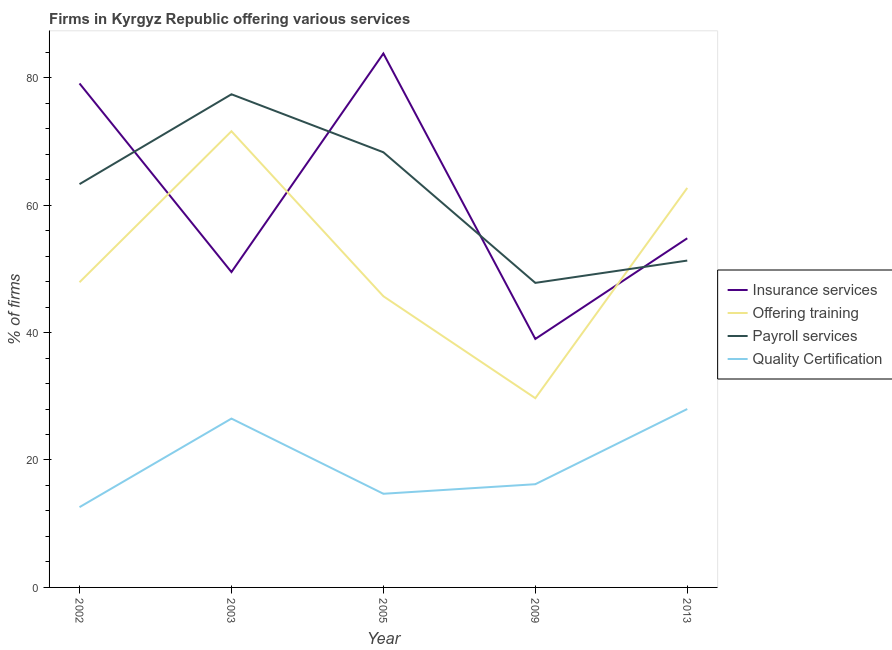Does the line corresponding to percentage of firms offering training intersect with the line corresponding to percentage of firms offering payroll services?
Keep it short and to the point. Yes. Is the number of lines equal to the number of legend labels?
Ensure brevity in your answer.  Yes. What is the percentage of firms offering insurance services in 2005?
Offer a terse response. 83.8. Across all years, what is the maximum percentage of firms offering insurance services?
Your answer should be compact. 83.8. Across all years, what is the minimum percentage of firms offering training?
Your answer should be very brief. 29.7. What is the total percentage of firms offering payroll services in the graph?
Give a very brief answer. 308.1. What is the difference between the percentage of firms offering payroll services in 2003 and that in 2013?
Provide a succinct answer. 26.1. What is the difference between the percentage of firms offering training in 2002 and the percentage of firms offering insurance services in 2003?
Your answer should be very brief. -1.6. What is the average percentage of firms offering payroll services per year?
Ensure brevity in your answer.  61.62. What is the ratio of the percentage of firms offering payroll services in 2005 to that in 2013?
Your response must be concise. 1.33. Is the difference between the percentage of firms offering quality certification in 2009 and 2013 greater than the difference between the percentage of firms offering training in 2009 and 2013?
Offer a terse response. Yes. What is the difference between the highest and the lowest percentage of firms offering payroll services?
Offer a very short reply. 29.6. In how many years, is the percentage of firms offering quality certification greater than the average percentage of firms offering quality certification taken over all years?
Provide a succinct answer. 2. Is the sum of the percentage of firms offering quality certification in 2002 and 2013 greater than the maximum percentage of firms offering training across all years?
Ensure brevity in your answer.  No. Is it the case that in every year, the sum of the percentage of firms offering quality certification and percentage of firms offering insurance services is greater than the sum of percentage of firms offering payroll services and percentage of firms offering training?
Your response must be concise. No. Does the percentage of firms offering insurance services monotonically increase over the years?
Keep it short and to the point. No. Is the percentage of firms offering payroll services strictly less than the percentage of firms offering training over the years?
Offer a very short reply. No. How many lines are there?
Offer a terse response. 4. How many years are there in the graph?
Provide a succinct answer. 5. Are the values on the major ticks of Y-axis written in scientific E-notation?
Ensure brevity in your answer.  No. Does the graph contain any zero values?
Give a very brief answer. No. Does the graph contain grids?
Keep it short and to the point. No. How are the legend labels stacked?
Make the answer very short. Vertical. What is the title of the graph?
Offer a terse response. Firms in Kyrgyz Republic offering various services . What is the label or title of the X-axis?
Your answer should be very brief. Year. What is the label or title of the Y-axis?
Your answer should be compact. % of firms. What is the % of firms in Insurance services in 2002?
Keep it short and to the point. 79.1. What is the % of firms in Offering training in 2002?
Make the answer very short. 47.9. What is the % of firms in Payroll services in 2002?
Ensure brevity in your answer.  63.3. What is the % of firms in Quality Certification in 2002?
Ensure brevity in your answer.  12.6. What is the % of firms of Insurance services in 2003?
Your response must be concise. 49.5. What is the % of firms of Offering training in 2003?
Your response must be concise. 71.6. What is the % of firms of Payroll services in 2003?
Your response must be concise. 77.4. What is the % of firms in Quality Certification in 2003?
Offer a terse response. 26.5. What is the % of firms in Insurance services in 2005?
Provide a succinct answer. 83.8. What is the % of firms in Offering training in 2005?
Provide a short and direct response. 45.7. What is the % of firms of Payroll services in 2005?
Your response must be concise. 68.3. What is the % of firms in Quality Certification in 2005?
Your response must be concise. 14.7. What is the % of firms in Insurance services in 2009?
Offer a very short reply. 39. What is the % of firms of Offering training in 2009?
Make the answer very short. 29.7. What is the % of firms of Payroll services in 2009?
Make the answer very short. 47.8. What is the % of firms in Insurance services in 2013?
Your response must be concise. 54.8. What is the % of firms of Offering training in 2013?
Provide a short and direct response. 62.7. What is the % of firms of Payroll services in 2013?
Make the answer very short. 51.3. What is the % of firms of Quality Certification in 2013?
Provide a succinct answer. 28. Across all years, what is the maximum % of firms of Insurance services?
Give a very brief answer. 83.8. Across all years, what is the maximum % of firms of Offering training?
Offer a very short reply. 71.6. Across all years, what is the maximum % of firms in Payroll services?
Ensure brevity in your answer.  77.4. Across all years, what is the minimum % of firms in Offering training?
Ensure brevity in your answer.  29.7. Across all years, what is the minimum % of firms in Payroll services?
Keep it short and to the point. 47.8. Across all years, what is the minimum % of firms in Quality Certification?
Give a very brief answer. 12.6. What is the total % of firms in Insurance services in the graph?
Give a very brief answer. 306.2. What is the total % of firms of Offering training in the graph?
Give a very brief answer. 257.6. What is the total % of firms in Payroll services in the graph?
Provide a succinct answer. 308.1. What is the difference between the % of firms in Insurance services in 2002 and that in 2003?
Your answer should be compact. 29.6. What is the difference between the % of firms of Offering training in 2002 and that in 2003?
Your response must be concise. -23.7. What is the difference between the % of firms in Payroll services in 2002 and that in 2003?
Provide a succinct answer. -14.1. What is the difference between the % of firms in Insurance services in 2002 and that in 2005?
Make the answer very short. -4.7. What is the difference between the % of firms of Quality Certification in 2002 and that in 2005?
Your response must be concise. -2.1. What is the difference between the % of firms in Insurance services in 2002 and that in 2009?
Provide a succinct answer. 40.1. What is the difference between the % of firms in Quality Certification in 2002 and that in 2009?
Provide a succinct answer. -3.6. What is the difference between the % of firms in Insurance services in 2002 and that in 2013?
Your response must be concise. 24.3. What is the difference between the % of firms of Offering training in 2002 and that in 2013?
Offer a very short reply. -14.8. What is the difference between the % of firms in Payroll services in 2002 and that in 2013?
Provide a short and direct response. 12. What is the difference between the % of firms of Quality Certification in 2002 and that in 2013?
Make the answer very short. -15.4. What is the difference between the % of firms in Insurance services in 2003 and that in 2005?
Give a very brief answer. -34.3. What is the difference between the % of firms of Offering training in 2003 and that in 2005?
Ensure brevity in your answer.  25.9. What is the difference between the % of firms in Quality Certification in 2003 and that in 2005?
Provide a short and direct response. 11.8. What is the difference between the % of firms of Offering training in 2003 and that in 2009?
Make the answer very short. 41.9. What is the difference between the % of firms of Payroll services in 2003 and that in 2009?
Your answer should be very brief. 29.6. What is the difference between the % of firms of Insurance services in 2003 and that in 2013?
Provide a succinct answer. -5.3. What is the difference between the % of firms in Payroll services in 2003 and that in 2013?
Keep it short and to the point. 26.1. What is the difference between the % of firms of Quality Certification in 2003 and that in 2013?
Your answer should be very brief. -1.5. What is the difference between the % of firms of Insurance services in 2005 and that in 2009?
Your answer should be very brief. 44.8. What is the difference between the % of firms in Offering training in 2005 and that in 2013?
Offer a very short reply. -17. What is the difference between the % of firms in Payroll services in 2005 and that in 2013?
Keep it short and to the point. 17. What is the difference between the % of firms in Insurance services in 2009 and that in 2013?
Provide a short and direct response. -15.8. What is the difference between the % of firms of Offering training in 2009 and that in 2013?
Keep it short and to the point. -33. What is the difference between the % of firms of Quality Certification in 2009 and that in 2013?
Your answer should be very brief. -11.8. What is the difference between the % of firms of Insurance services in 2002 and the % of firms of Offering training in 2003?
Provide a short and direct response. 7.5. What is the difference between the % of firms of Insurance services in 2002 and the % of firms of Payroll services in 2003?
Provide a short and direct response. 1.7. What is the difference between the % of firms of Insurance services in 2002 and the % of firms of Quality Certification in 2003?
Give a very brief answer. 52.6. What is the difference between the % of firms in Offering training in 2002 and the % of firms in Payroll services in 2003?
Make the answer very short. -29.5. What is the difference between the % of firms in Offering training in 2002 and the % of firms in Quality Certification in 2003?
Provide a short and direct response. 21.4. What is the difference between the % of firms of Payroll services in 2002 and the % of firms of Quality Certification in 2003?
Give a very brief answer. 36.8. What is the difference between the % of firms of Insurance services in 2002 and the % of firms of Offering training in 2005?
Provide a short and direct response. 33.4. What is the difference between the % of firms of Insurance services in 2002 and the % of firms of Quality Certification in 2005?
Ensure brevity in your answer.  64.4. What is the difference between the % of firms in Offering training in 2002 and the % of firms in Payroll services in 2005?
Make the answer very short. -20.4. What is the difference between the % of firms of Offering training in 2002 and the % of firms of Quality Certification in 2005?
Keep it short and to the point. 33.2. What is the difference between the % of firms of Payroll services in 2002 and the % of firms of Quality Certification in 2005?
Keep it short and to the point. 48.6. What is the difference between the % of firms in Insurance services in 2002 and the % of firms in Offering training in 2009?
Give a very brief answer. 49.4. What is the difference between the % of firms in Insurance services in 2002 and the % of firms in Payroll services in 2009?
Offer a terse response. 31.3. What is the difference between the % of firms of Insurance services in 2002 and the % of firms of Quality Certification in 2009?
Offer a terse response. 62.9. What is the difference between the % of firms of Offering training in 2002 and the % of firms of Quality Certification in 2009?
Your answer should be very brief. 31.7. What is the difference between the % of firms in Payroll services in 2002 and the % of firms in Quality Certification in 2009?
Provide a succinct answer. 47.1. What is the difference between the % of firms of Insurance services in 2002 and the % of firms of Offering training in 2013?
Give a very brief answer. 16.4. What is the difference between the % of firms in Insurance services in 2002 and the % of firms in Payroll services in 2013?
Make the answer very short. 27.8. What is the difference between the % of firms in Insurance services in 2002 and the % of firms in Quality Certification in 2013?
Give a very brief answer. 51.1. What is the difference between the % of firms in Offering training in 2002 and the % of firms in Quality Certification in 2013?
Provide a succinct answer. 19.9. What is the difference between the % of firms in Payroll services in 2002 and the % of firms in Quality Certification in 2013?
Provide a succinct answer. 35.3. What is the difference between the % of firms of Insurance services in 2003 and the % of firms of Payroll services in 2005?
Provide a short and direct response. -18.8. What is the difference between the % of firms of Insurance services in 2003 and the % of firms of Quality Certification in 2005?
Offer a very short reply. 34.8. What is the difference between the % of firms of Offering training in 2003 and the % of firms of Quality Certification in 2005?
Keep it short and to the point. 56.9. What is the difference between the % of firms in Payroll services in 2003 and the % of firms in Quality Certification in 2005?
Ensure brevity in your answer.  62.7. What is the difference between the % of firms in Insurance services in 2003 and the % of firms in Offering training in 2009?
Offer a very short reply. 19.8. What is the difference between the % of firms of Insurance services in 2003 and the % of firms of Payroll services in 2009?
Give a very brief answer. 1.7. What is the difference between the % of firms in Insurance services in 2003 and the % of firms in Quality Certification in 2009?
Ensure brevity in your answer.  33.3. What is the difference between the % of firms of Offering training in 2003 and the % of firms of Payroll services in 2009?
Ensure brevity in your answer.  23.8. What is the difference between the % of firms in Offering training in 2003 and the % of firms in Quality Certification in 2009?
Provide a succinct answer. 55.4. What is the difference between the % of firms of Payroll services in 2003 and the % of firms of Quality Certification in 2009?
Your answer should be very brief. 61.2. What is the difference between the % of firms in Insurance services in 2003 and the % of firms in Offering training in 2013?
Give a very brief answer. -13.2. What is the difference between the % of firms in Offering training in 2003 and the % of firms in Payroll services in 2013?
Give a very brief answer. 20.3. What is the difference between the % of firms of Offering training in 2003 and the % of firms of Quality Certification in 2013?
Provide a short and direct response. 43.6. What is the difference between the % of firms in Payroll services in 2003 and the % of firms in Quality Certification in 2013?
Provide a short and direct response. 49.4. What is the difference between the % of firms of Insurance services in 2005 and the % of firms of Offering training in 2009?
Your answer should be very brief. 54.1. What is the difference between the % of firms of Insurance services in 2005 and the % of firms of Quality Certification in 2009?
Ensure brevity in your answer.  67.6. What is the difference between the % of firms of Offering training in 2005 and the % of firms of Quality Certification in 2009?
Your response must be concise. 29.5. What is the difference between the % of firms in Payroll services in 2005 and the % of firms in Quality Certification in 2009?
Provide a short and direct response. 52.1. What is the difference between the % of firms of Insurance services in 2005 and the % of firms of Offering training in 2013?
Provide a succinct answer. 21.1. What is the difference between the % of firms of Insurance services in 2005 and the % of firms of Payroll services in 2013?
Make the answer very short. 32.5. What is the difference between the % of firms of Insurance services in 2005 and the % of firms of Quality Certification in 2013?
Your response must be concise. 55.8. What is the difference between the % of firms in Offering training in 2005 and the % of firms in Quality Certification in 2013?
Keep it short and to the point. 17.7. What is the difference between the % of firms of Payroll services in 2005 and the % of firms of Quality Certification in 2013?
Provide a succinct answer. 40.3. What is the difference between the % of firms in Insurance services in 2009 and the % of firms in Offering training in 2013?
Provide a succinct answer. -23.7. What is the difference between the % of firms in Insurance services in 2009 and the % of firms in Payroll services in 2013?
Your response must be concise. -12.3. What is the difference between the % of firms in Offering training in 2009 and the % of firms in Payroll services in 2013?
Your response must be concise. -21.6. What is the difference between the % of firms of Payroll services in 2009 and the % of firms of Quality Certification in 2013?
Your answer should be very brief. 19.8. What is the average % of firms of Insurance services per year?
Offer a very short reply. 61.24. What is the average % of firms of Offering training per year?
Offer a very short reply. 51.52. What is the average % of firms in Payroll services per year?
Keep it short and to the point. 61.62. What is the average % of firms in Quality Certification per year?
Your response must be concise. 19.6. In the year 2002, what is the difference between the % of firms in Insurance services and % of firms in Offering training?
Give a very brief answer. 31.2. In the year 2002, what is the difference between the % of firms in Insurance services and % of firms in Payroll services?
Ensure brevity in your answer.  15.8. In the year 2002, what is the difference between the % of firms of Insurance services and % of firms of Quality Certification?
Keep it short and to the point. 66.5. In the year 2002, what is the difference between the % of firms in Offering training and % of firms in Payroll services?
Your answer should be very brief. -15.4. In the year 2002, what is the difference between the % of firms of Offering training and % of firms of Quality Certification?
Offer a terse response. 35.3. In the year 2002, what is the difference between the % of firms in Payroll services and % of firms in Quality Certification?
Make the answer very short. 50.7. In the year 2003, what is the difference between the % of firms in Insurance services and % of firms in Offering training?
Make the answer very short. -22.1. In the year 2003, what is the difference between the % of firms of Insurance services and % of firms of Payroll services?
Offer a very short reply. -27.9. In the year 2003, what is the difference between the % of firms of Insurance services and % of firms of Quality Certification?
Your answer should be compact. 23. In the year 2003, what is the difference between the % of firms in Offering training and % of firms in Payroll services?
Your answer should be very brief. -5.8. In the year 2003, what is the difference between the % of firms in Offering training and % of firms in Quality Certification?
Provide a succinct answer. 45.1. In the year 2003, what is the difference between the % of firms of Payroll services and % of firms of Quality Certification?
Provide a succinct answer. 50.9. In the year 2005, what is the difference between the % of firms in Insurance services and % of firms in Offering training?
Provide a succinct answer. 38.1. In the year 2005, what is the difference between the % of firms in Insurance services and % of firms in Quality Certification?
Your answer should be very brief. 69.1. In the year 2005, what is the difference between the % of firms of Offering training and % of firms of Payroll services?
Give a very brief answer. -22.6. In the year 2005, what is the difference between the % of firms in Offering training and % of firms in Quality Certification?
Your response must be concise. 31. In the year 2005, what is the difference between the % of firms of Payroll services and % of firms of Quality Certification?
Your response must be concise. 53.6. In the year 2009, what is the difference between the % of firms of Insurance services and % of firms of Offering training?
Your answer should be compact. 9.3. In the year 2009, what is the difference between the % of firms of Insurance services and % of firms of Payroll services?
Make the answer very short. -8.8. In the year 2009, what is the difference between the % of firms of Insurance services and % of firms of Quality Certification?
Keep it short and to the point. 22.8. In the year 2009, what is the difference between the % of firms in Offering training and % of firms in Payroll services?
Offer a very short reply. -18.1. In the year 2009, what is the difference between the % of firms of Payroll services and % of firms of Quality Certification?
Make the answer very short. 31.6. In the year 2013, what is the difference between the % of firms in Insurance services and % of firms in Payroll services?
Offer a terse response. 3.5. In the year 2013, what is the difference between the % of firms of Insurance services and % of firms of Quality Certification?
Your answer should be compact. 26.8. In the year 2013, what is the difference between the % of firms of Offering training and % of firms of Quality Certification?
Your answer should be compact. 34.7. In the year 2013, what is the difference between the % of firms of Payroll services and % of firms of Quality Certification?
Ensure brevity in your answer.  23.3. What is the ratio of the % of firms of Insurance services in 2002 to that in 2003?
Provide a succinct answer. 1.6. What is the ratio of the % of firms in Offering training in 2002 to that in 2003?
Provide a short and direct response. 0.67. What is the ratio of the % of firms of Payroll services in 2002 to that in 2003?
Offer a very short reply. 0.82. What is the ratio of the % of firms in Quality Certification in 2002 to that in 2003?
Ensure brevity in your answer.  0.48. What is the ratio of the % of firms of Insurance services in 2002 to that in 2005?
Your answer should be compact. 0.94. What is the ratio of the % of firms in Offering training in 2002 to that in 2005?
Provide a short and direct response. 1.05. What is the ratio of the % of firms in Payroll services in 2002 to that in 2005?
Offer a terse response. 0.93. What is the ratio of the % of firms of Quality Certification in 2002 to that in 2005?
Your answer should be compact. 0.86. What is the ratio of the % of firms in Insurance services in 2002 to that in 2009?
Your answer should be very brief. 2.03. What is the ratio of the % of firms in Offering training in 2002 to that in 2009?
Offer a very short reply. 1.61. What is the ratio of the % of firms in Payroll services in 2002 to that in 2009?
Provide a short and direct response. 1.32. What is the ratio of the % of firms of Insurance services in 2002 to that in 2013?
Provide a succinct answer. 1.44. What is the ratio of the % of firms in Offering training in 2002 to that in 2013?
Give a very brief answer. 0.76. What is the ratio of the % of firms of Payroll services in 2002 to that in 2013?
Provide a succinct answer. 1.23. What is the ratio of the % of firms of Quality Certification in 2002 to that in 2013?
Provide a short and direct response. 0.45. What is the ratio of the % of firms of Insurance services in 2003 to that in 2005?
Provide a short and direct response. 0.59. What is the ratio of the % of firms in Offering training in 2003 to that in 2005?
Provide a succinct answer. 1.57. What is the ratio of the % of firms of Payroll services in 2003 to that in 2005?
Provide a succinct answer. 1.13. What is the ratio of the % of firms of Quality Certification in 2003 to that in 2005?
Provide a short and direct response. 1.8. What is the ratio of the % of firms in Insurance services in 2003 to that in 2009?
Your answer should be very brief. 1.27. What is the ratio of the % of firms of Offering training in 2003 to that in 2009?
Provide a succinct answer. 2.41. What is the ratio of the % of firms in Payroll services in 2003 to that in 2009?
Your answer should be very brief. 1.62. What is the ratio of the % of firms of Quality Certification in 2003 to that in 2009?
Make the answer very short. 1.64. What is the ratio of the % of firms of Insurance services in 2003 to that in 2013?
Give a very brief answer. 0.9. What is the ratio of the % of firms in Offering training in 2003 to that in 2013?
Your answer should be very brief. 1.14. What is the ratio of the % of firms in Payroll services in 2003 to that in 2013?
Your response must be concise. 1.51. What is the ratio of the % of firms of Quality Certification in 2003 to that in 2013?
Offer a terse response. 0.95. What is the ratio of the % of firms of Insurance services in 2005 to that in 2009?
Make the answer very short. 2.15. What is the ratio of the % of firms in Offering training in 2005 to that in 2009?
Your answer should be very brief. 1.54. What is the ratio of the % of firms of Payroll services in 2005 to that in 2009?
Keep it short and to the point. 1.43. What is the ratio of the % of firms of Quality Certification in 2005 to that in 2009?
Provide a short and direct response. 0.91. What is the ratio of the % of firms of Insurance services in 2005 to that in 2013?
Ensure brevity in your answer.  1.53. What is the ratio of the % of firms in Offering training in 2005 to that in 2013?
Offer a very short reply. 0.73. What is the ratio of the % of firms of Payroll services in 2005 to that in 2013?
Offer a very short reply. 1.33. What is the ratio of the % of firms in Quality Certification in 2005 to that in 2013?
Your answer should be very brief. 0.53. What is the ratio of the % of firms in Insurance services in 2009 to that in 2013?
Make the answer very short. 0.71. What is the ratio of the % of firms in Offering training in 2009 to that in 2013?
Your answer should be very brief. 0.47. What is the ratio of the % of firms in Payroll services in 2009 to that in 2013?
Keep it short and to the point. 0.93. What is the ratio of the % of firms of Quality Certification in 2009 to that in 2013?
Ensure brevity in your answer.  0.58. What is the difference between the highest and the second highest % of firms of Insurance services?
Give a very brief answer. 4.7. What is the difference between the highest and the second highest % of firms in Quality Certification?
Provide a short and direct response. 1.5. What is the difference between the highest and the lowest % of firms of Insurance services?
Your answer should be very brief. 44.8. What is the difference between the highest and the lowest % of firms in Offering training?
Keep it short and to the point. 41.9. What is the difference between the highest and the lowest % of firms in Payroll services?
Ensure brevity in your answer.  29.6. What is the difference between the highest and the lowest % of firms in Quality Certification?
Make the answer very short. 15.4. 